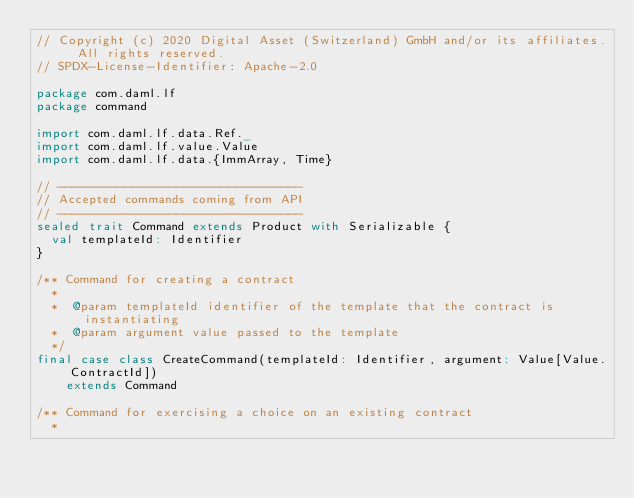<code> <loc_0><loc_0><loc_500><loc_500><_Scala_>// Copyright (c) 2020 Digital Asset (Switzerland) GmbH and/or its affiliates. All rights reserved.
// SPDX-License-Identifier: Apache-2.0

package com.daml.lf
package command

import com.daml.lf.data.Ref._
import com.daml.lf.value.Value
import com.daml.lf.data.{ImmArray, Time}

// ---------------------------------
// Accepted commands coming from API
// ---------------------------------
sealed trait Command extends Product with Serializable {
  val templateId: Identifier
}

/** Command for creating a contract
  *
  *  @param templateId identifier of the template that the contract is instantiating
  *  @param argument value passed to the template
  */
final case class CreateCommand(templateId: Identifier, argument: Value[Value.ContractId])
    extends Command

/** Command for exercising a choice on an existing contract
  *</code> 